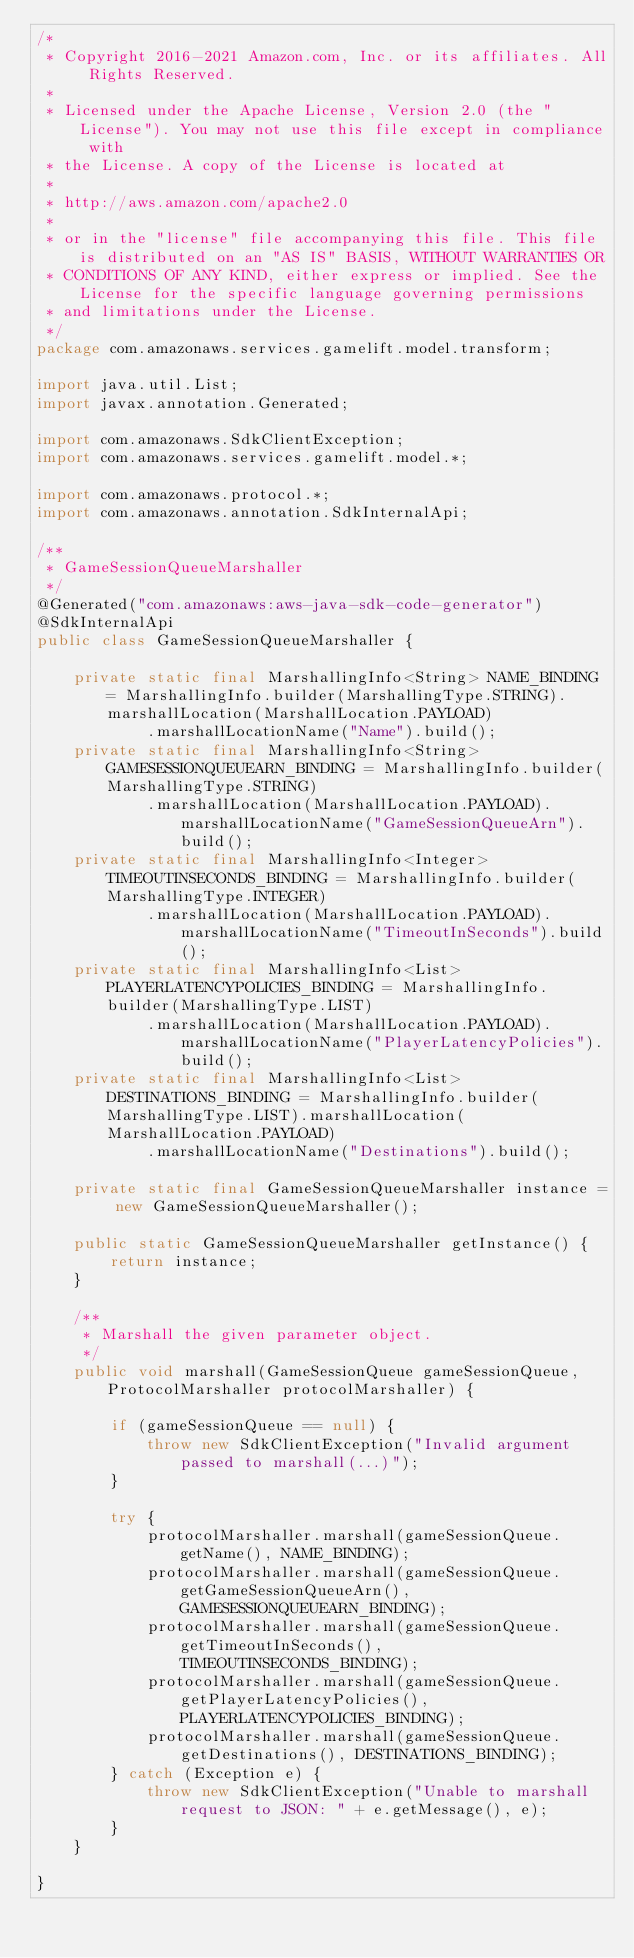Convert code to text. <code><loc_0><loc_0><loc_500><loc_500><_Java_>/*
 * Copyright 2016-2021 Amazon.com, Inc. or its affiliates. All Rights Reserved.
 * 
 * Licensed under the Apache License, Version 2.0 (the "License"). You may not use this file except in compliance with
 * the License. A copy of the License is located at
 * 
 * http://aws.amazon.com/apache2.0
 * 
 * or in the "license" file accompanying this file. This file is distributed on an "AS IS" BASIS, WITHOUT WARRANTIES OR
 * CONDITIONS OF ANY KIND, either express or implied. See the License for the specific language governing permissions
 * and limitations under the License.
 */
package com.amazonaws.services.gamelift.model.transform;

import java.util.List;
import javax.annotation.Generated;

import com.amazonaws.SdkClientException;
import com.amazonaws.services.gamelift.model.*;

import com.amazonaws.protocol.*;
import com.amazonaws.annotation.SdkInternalApi;

/**
 * GameSessionQueueMarshaller
 */
@Generated("com.amazonaws:aws-java-sdk-code-generator")
@SdkInternalApi
public class GameSessionQueueMarshaller {

    private static final MarshallingInfo<String> NAME_BINDING = MarshallingInfo.builder(MarshallingType.STRING).marshallLocation(MarshallLocation.PAYLOAD)
            .marshallLocationName("Name").build();
    private static final MarshallingInfo<String> GAMESESSIONQUEUEARN_BINDING = MarshallingInfo.builder(MarshallingType.STRING)
            .marshallLocation(MarshallLocation.PAYLOAD).marshallLocationName("GameSessionQueueArn").build();
    private static final MarshallingInfo<Integer> TIMEOUTINSECONDS_BINDING = MarshallingInfo.builder(MarshallingType.INTEGER)
            .marshallLocation(MarshallLocation.PAYLOAD).marshallLocationName("TimeoutInSeconds").build();
    private static final MarshallingInfo<List> PLAYERLATENCYPOLICIES_BINDING = MarshallingInfo.builder(MarshallingType.LIST)
            .marshallLocation(MarshallLocation.PAYLOAD).marshallLocationName("PlayerLatencyPolicies").build();
    private static final MarshallingInfo<List> DESTINATIONS_BINDING = MarshallingInfo.builder(MarshallingType.LIST).marshallLocation(MarshallLocation.PAYLOAD)
            .marshallLocationName("Destinations").build();

    private static final GameSessionQueueMarshaller instance = new GameSessionQueueMarshaller();

    public static GameSessionQueueMarshaller getInstance() {
        return instance;
    }

    /**
     * Marshall the given parameter object.
     */
    public void marshall(GameSessionQueue gameSessionQueue, ProtocolMarshaller protocolMarshaller) {

        if (gameSessionQueue == null) {
            throw new SdkClientException("Invalid argument passed to marshall(...)");
        }

        try {
            protocolMarshaller.marshall(gameSessionQueue.getName(), NAME_BINDING);
            protocolMarshaller.marshall(gameSessionQueue.getGameSessionQueueArn(), GAMESESSIONQUEUEARN_BINDING);
            protocolMarshaller.marshall(gameSessionQueue.getTimeoutInSeconds(), TIMEOUTINSECONDS_BINDING);
            protocolMarshaller.marshall(gameSessionQueue.getPlayerLatencyPolicies(), PLAYERLATENCYPOLICIES_BINDING);
            protocolMarshaller.marshall(gameSessionQueue.getDestinations(), DESTINATIONS_BINDING);
        } catch (Exception e) {
            throw new SdkClientException("Unable to marshall request to JSON: " + e.getMessage(), e);
        }
    }

}
</code> 